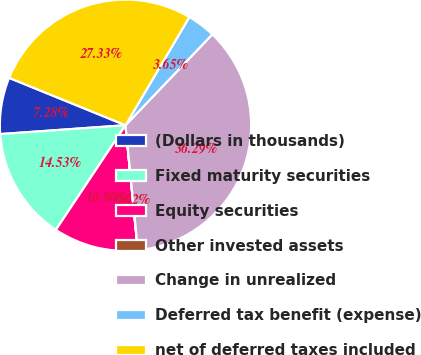Convert chart. <chart><loc_0><loc_0><loc_500><loc_500><pie_chart><fcel>(Dollars in thousands)<fcel>Fixed maturity securities<fcel>Equity securities<fcel>Other invested assets<fcel>Change in unrealized<fcel>Deferred tax benefit (expense)<fcel>net of deferred taxes included<nl><fcel>7.28%<fcel>14.53%<fcel>10.9%<fcel>0.02%<fcel>36.29%<fcel>3.65%<fcel>27.33%<nl></chart> 